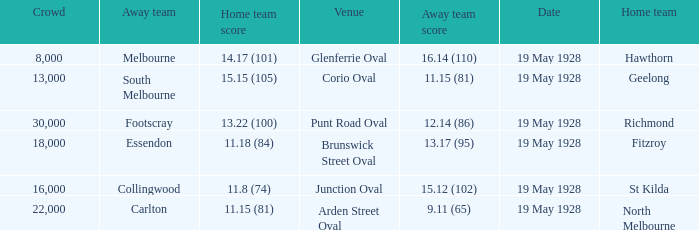What was the listed crowd at junction oval? 16000.0. 